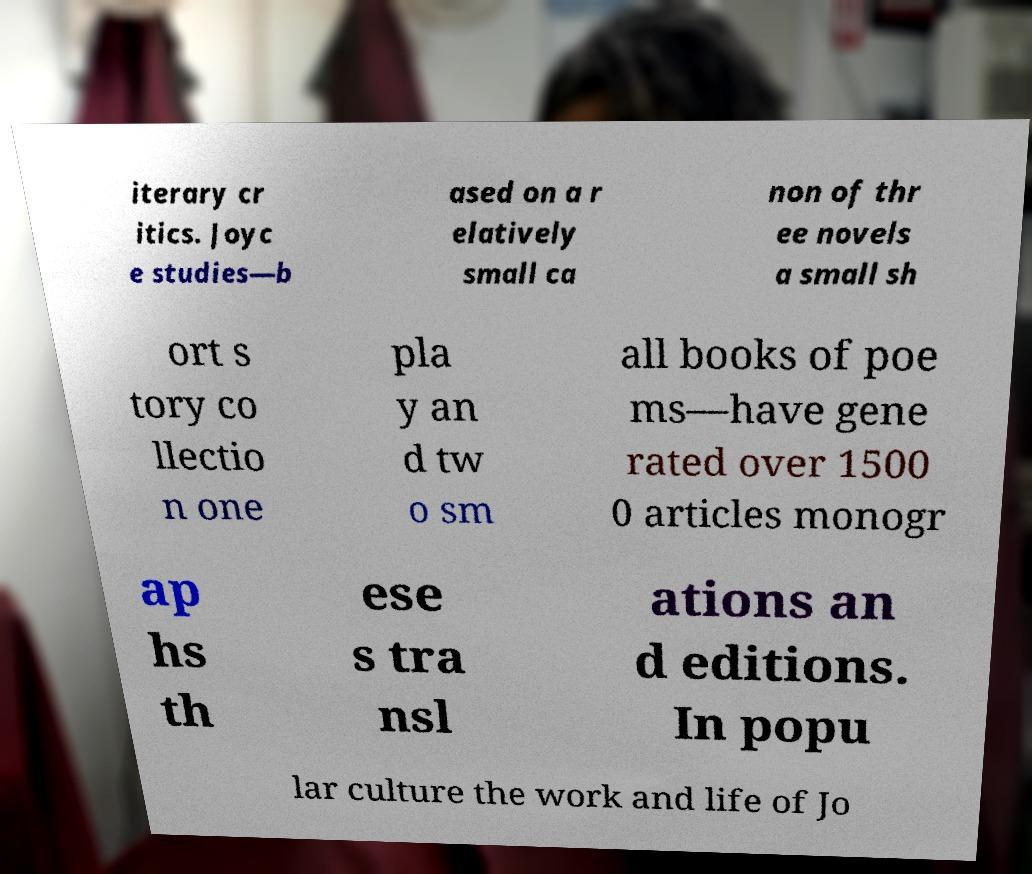Could you assist in decoding the text presented in this image and type it out clearly? iterary cr itics. Joyc e studies—b ased on a r elatively small ca non of thr ee novels a small sh ort s tory co llectio n one pla y an d tw o sm all books of poe ms—have gene rated over 1500 0 articles monogr ap hs th ese s tra nsl ations an d editions. In popu lar culture the work and life of Jo 